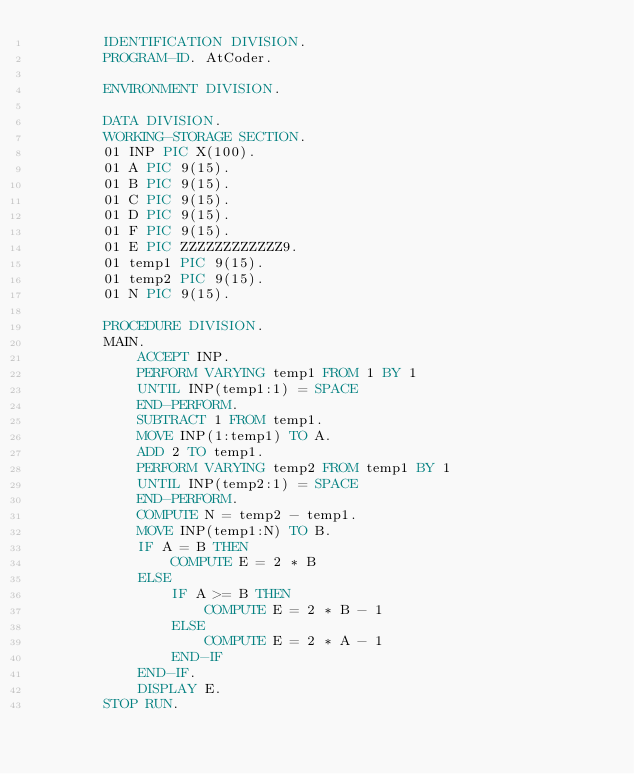Convert code to text. <code><loc_0><loc_0><loc_500><loc_500><_COBOL_>		IDENTIFICATION DIVISION.
        PROGRAM-ID. AtCoder.
      
        ENVIRONMENT DIVISION.
      
        DATA DIVISION.
        WORKING-STORAGE SECTION.
        01 INP PIC X(100).
        01 A PIC 9(15).
        01 B PIC 9(15).
        01 C PIC 9(15).
      	01 D PIC 9(15).
      	01 F PIC 9(15).
      	01 E PIC ZZZZZZZZZZZZ9.
	    01 temp1 PIC 9(15).
        01 temp2 PIC 9(15).
        01 N PIC 9(15).
      
        PROCEDURE DIVISION.
      	MAIN.
			ACCEPT INP.
        	PERFORM VARYING temp1 FROM 1 BY 1
            UNTIL INP(temp1:1) = SPACE
        	END-PERFORM.
        	SUBTRACT 1 FROM temp1.
        	MOVE INP(1:temp1) TO A.
        	ADD 2 TO temp1.
        	PERFORM VARYING temp2 FROM temp1 BY 1
            UNTIL INP(temp2:1) = SPACE
        	END-PERFORM.
        	COMPUTE N = temp2 - temp1.
        	MOVE INP(temp1:N) TO B.
      		IF A = B THEN
      			COMPUTE E = 2 * B
      		ELSE
      			IF A >= B THEN
      				COMPUTE E = 2 * B - 1
      			ELSE
      				COMPUTE E = 2 * A - 1
      			END-IF
      		END-IF.
      		DISPLAY E.
		STOP RUN.</code> 